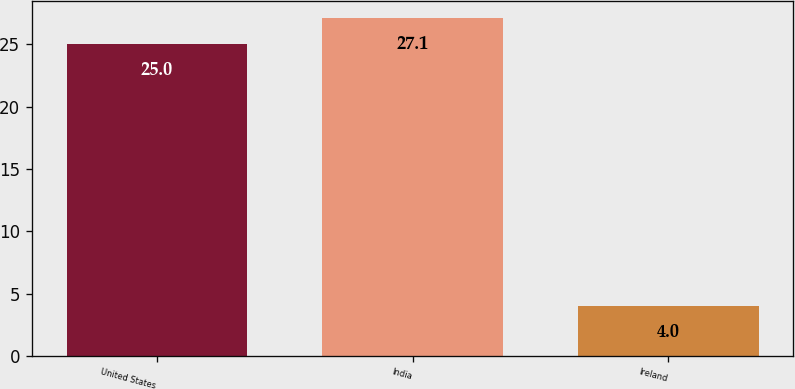Convert chart. <chart><loc_0><loc_0><loc_500><loc_500><bar_chart><fcel>United States<fcel>India<fcel>Ireland<nl><fcel>25<fcel>27.1<fcel>4<nl></chart> 